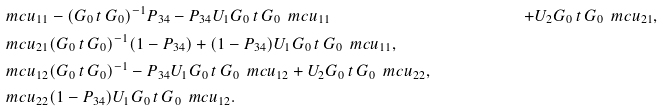Convert formula to latex. <formula><loc_0><loc_0><loc_500><loc_500>\ m c u _ { 1 1 } & - ( G _ { 0 } \, t \, G _ { 0 } ) ^ { - 1 } P _ { 3 4 } - P _ { 3 4 } U _ { 1 } G _ { 0 } \, t \, G _ { 0 } \, \ m c u _ { 1 1 } & + U _ { 2 } G _ { 0 } \, t \, G _ { 0 } \, \ m c u _ { 2 1 } , \\ \ m c u _ { 2 1 } & ( G _ { 0 } \, t \, G _ { 0 } ) ^ { - 1 } ( 1 - P _ { 3 4 } ) + ( 1 - P _ { 3 4 } ) U _ { 1 } G _ { 0 } \, t \, G _ { 0 } \, \ m c u _ { 1 1 } , \\ \ m c u _ { 1 2 } & ( G _ { 0 } \, t \, G _ { 0 } ) ^ { - 1 } - P _ { 3 4 } U _ { 1 } G _ { 0 } \, t \, G _ { 0 } \, \ m c u _ { 1 2 } + U _ { 2 } G _ { 0 } \, t \, G _ { 0 } \, \ m c u _ { 2 2 } , \\ \ m c u _ { 2 2 } & ( 1 - P _ { 3 4 } ) U _ { 1 } G _ { 0 } \, t \, G _ { 0 } \, \ m c u _ { 1 2 } .</formula> 